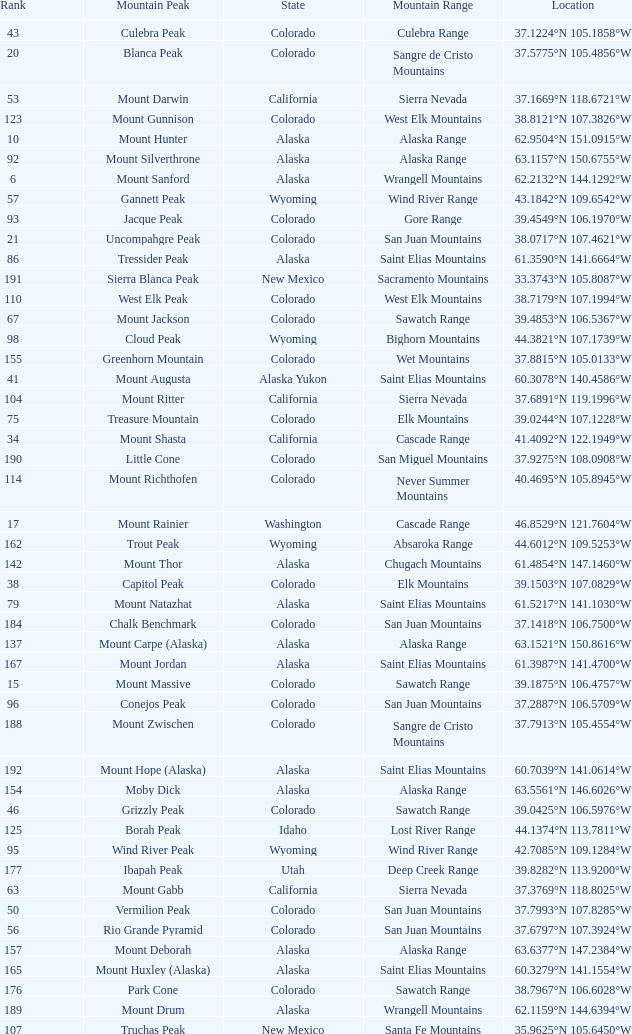What is the mountain peak when the location is 37.5775°n 105.4856°w? Blanca Peak. 